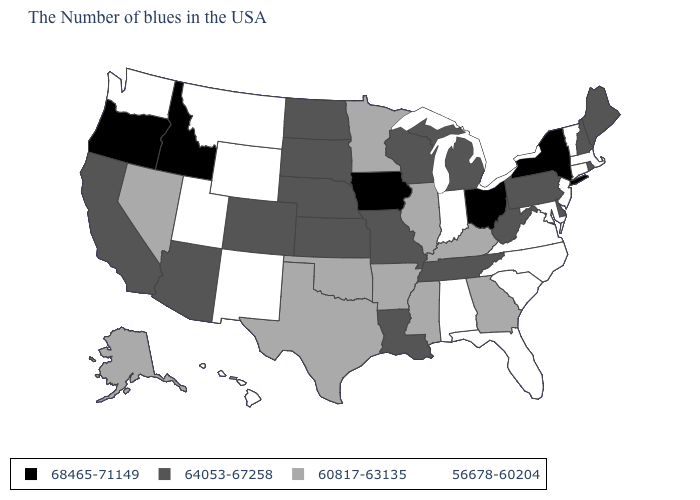Among the states that border Mississippi , which have the lowest value?
Give a very brief answer. Alabama. Does Hawaii have the lowest value in the West?
Short answer required. Yes. What is the value of Texas?
Answer briefly. 60817-63135. Among the states that border North Carolina , which have the lowest value?
Keep it brief. Virginia, South Carolina. Name the states that have a value in the range 64053-67258?
Give a very brief answer. Maine, Rhode Island, New Hampshire, Delaware, Pennsylvania, West Virginia, Michigan, Tennessee, Wisconsin, Louisiana, Missouri, Kansas, Nebraska, South Dakota, North Dakota, Colorado, Arizona, California. Name the states that have a value in the range 60817-63135?
Short answer required. Georgia, Kentucky, Illinois, Mississippi, Arkansas, Minnesota, Oklahoma, Texas, Nevada, Alaska. What is the value of Iowa?
Give a very brief answer. 68465-71149. What is the value of Washington?
Write a very short answer. 56678-60204. Among the states that border Montana , does Wyoming have the highest value?
Keep it brief. No. What is the lowest value in the MidWest?
Keep it brief. 56678-60204. What is the value of Mississippi?
Quick response, please. 60817-63135. Does Alaska have the lowest value in the USA?
Short answer required. No. Which states hav the highest value in the MidWest?
Give a very brief answer. Ohio, Iowa. What is the value of Connecticut?
Answer briefly. 56678-60204. 